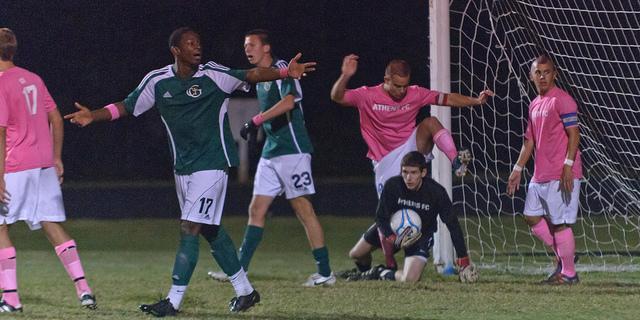How many people are there?
Give a very brief answer. 6. 